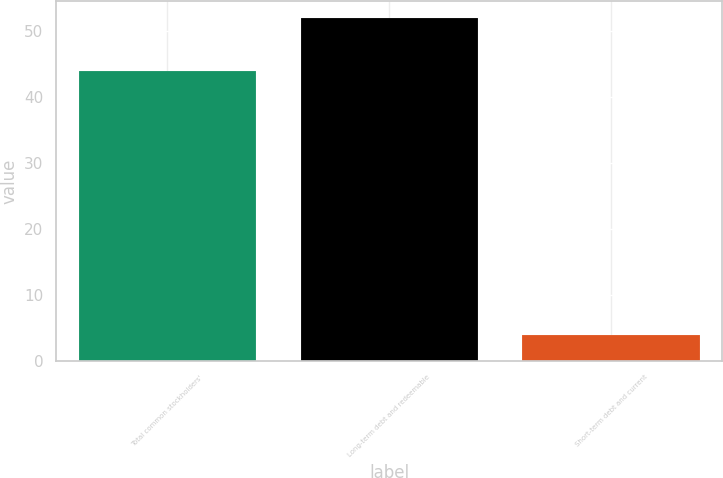Convert chart. <chart><loc_0><loc_0><loc_500><loc_500><bar_chart><fcel>Total common stockholders'<fcel>Long-term debt and redeemable<fcel>Short-term debt and current<nl><fcel>44<fcel>52<fcel>4<nl></chart> 